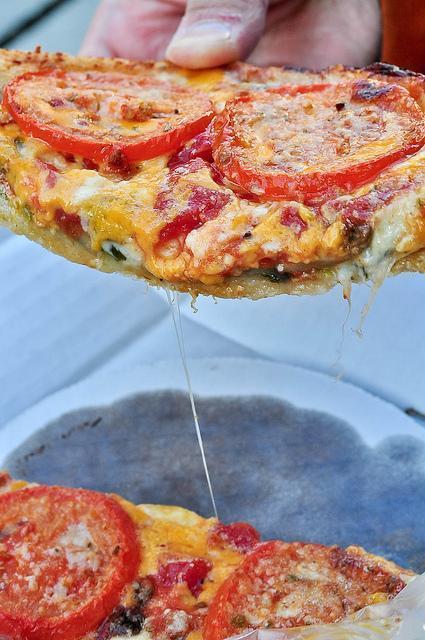How many pizzas are there?
Give a very brief answer. 2. 